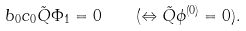<formula> <loc_0><loc_0><loc_500><loc_500>b _ { 0 } c _ { 0 } \tilde { Q } \Phi _ { 1 } = 0 \quad ( \Leftrightarrow \tilde { Q } \phi ^ { ( 0 ) } = 0 ) .</formula> 